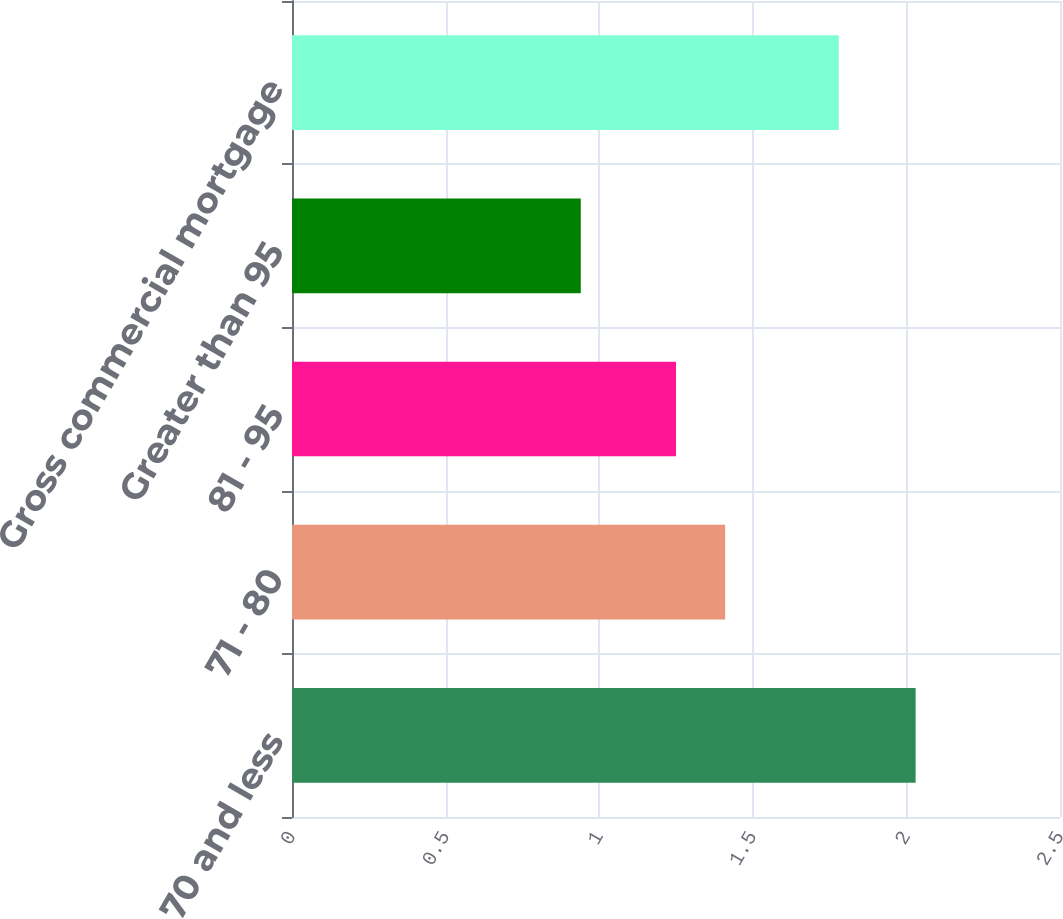Convert chart. <chart><loc_0><loc_0><loc_500><loc_500><bar_chart><fcel>70 and less<fcel>71 - 80<fcel>81 - 95<fcel>Greater than 95<fcel>Gross commercial mortgage<nl><fcel>2.03<fcel>1.41<fcel>1.25<fcel>0.94<fcel>1.78<nl></chart> 